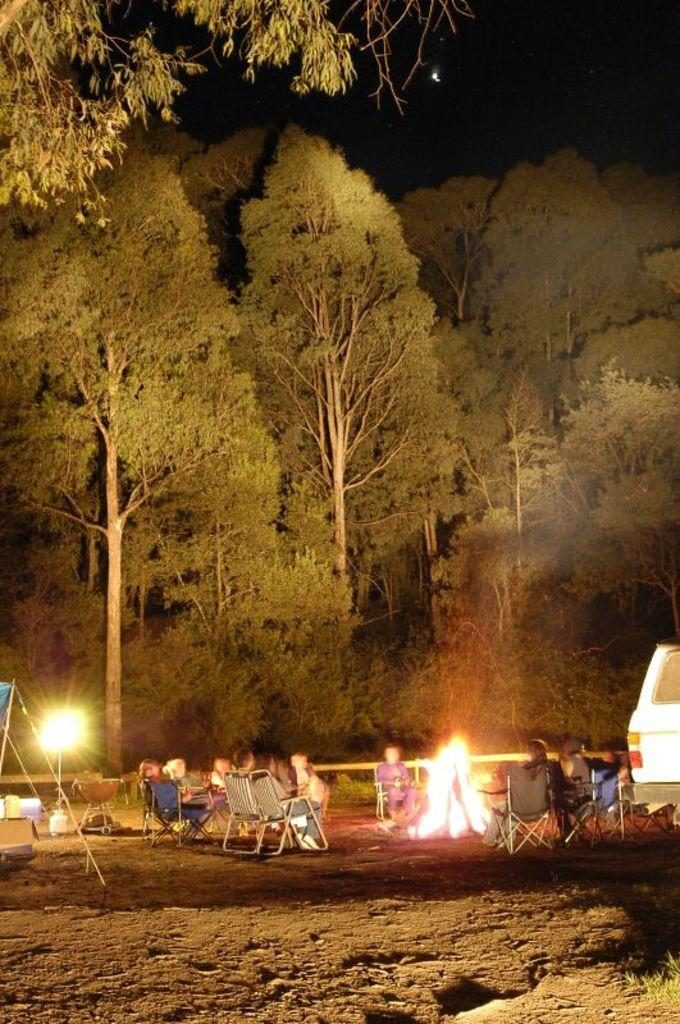How many people are in the image? There is a group of people in the image. What are the people doing in the image? The people are sitting on chairs. What can be seen in the image besides the people and chairs? There is fire visible in the image, a vehicle on the ground, and trees in the background. How many legs does the goat have in the image? There is no goat present in the image. What type of slip can be seen on the people's feet in the image? There is no mention of any slip or footwear on the people's feet in the image. 